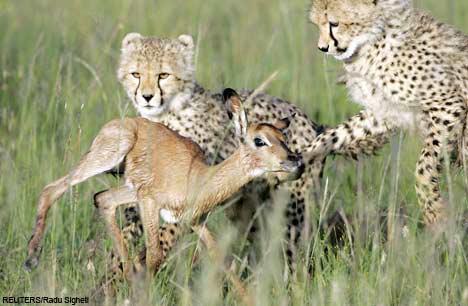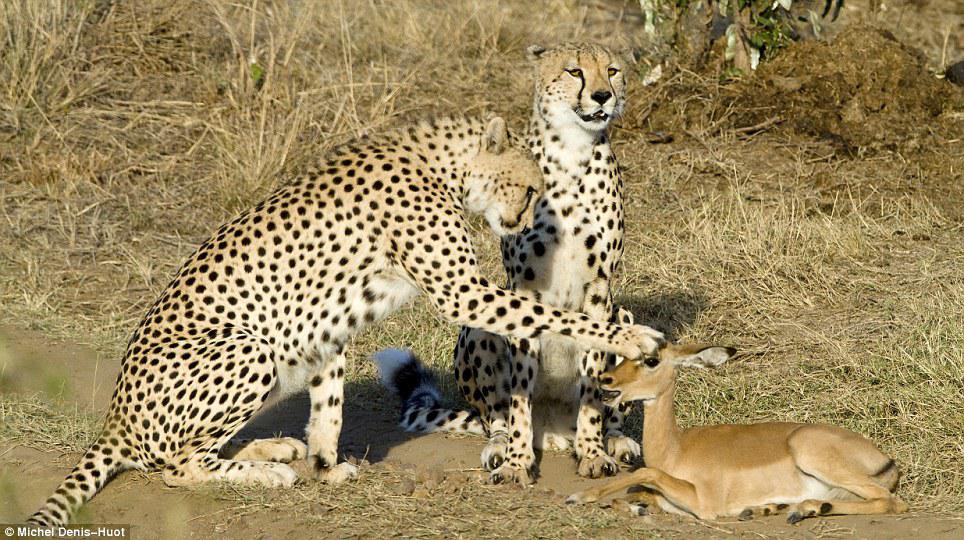The first image is the image on the left, the second image is the image on the right. For the images displayed, is the sentence "There are two baby cheetahs hunting a baby gazelle." factually correct? Answer yes or no. Yes. 